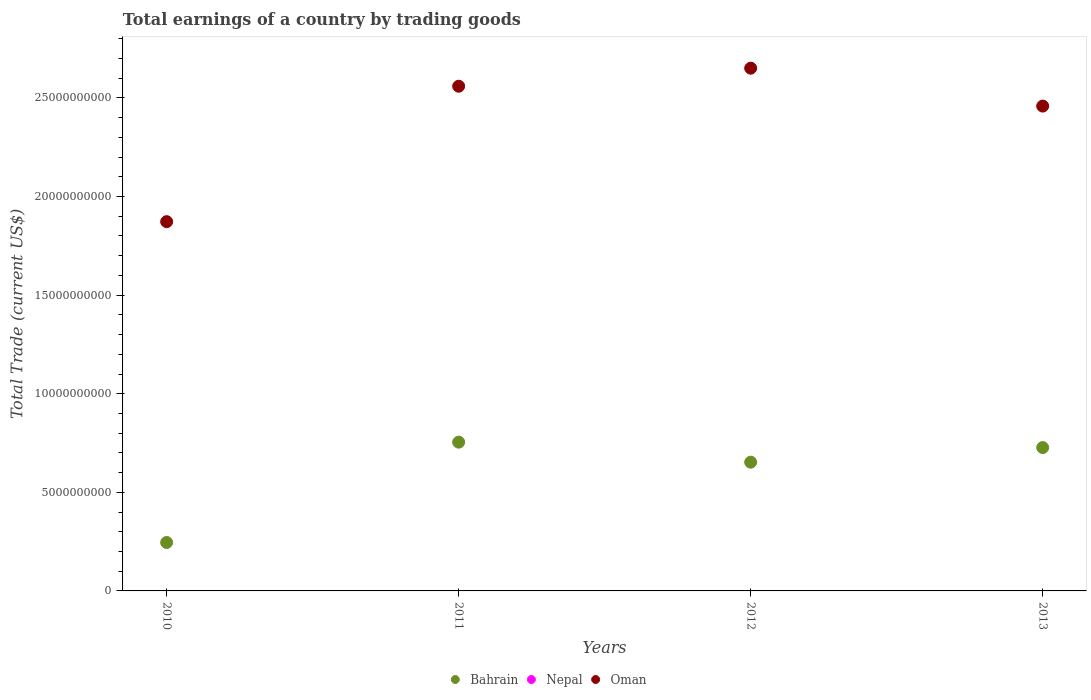What is the total earnings in Bahrain in 2010?
Make the answer very short. 2.46e+09. Across all years, what is the maximum total earnings in Oman?
Offer a terse response. 2.65e+1. Across all years, what is the minimum total earnings in Bahrain?
Make the answer very short. 2.46e+09. In which year was the total earnings in Bahrain maximum?
Keep it short and to the point. 2011. What is the total total earnings in Bahrain in the graph?
Your answer should be compact. 2.38e+1. What is the difference between the total earnings in Oman in 2012 and that in 2013?
Your answer should be very brief. 1.92e+09. What is the difference between the total earnings in Oman in 2013 and the total earnings in Bahrain in 2010?
Your answer should be very brief. 2.21e+1. In the year 2010, what is the difference between the total earnings in Bahrain and total earnings in Oman?
Keep it short and to the point. -1.63e+1. What is the ratio of the total earnings in Oman in 2010 to that in 2012?
Provide a succinct answer. 0.71. Is the difference between the total earnings in Bahrain in 2010 and 2011 greater than the difference between the total earnings in Oman in 2010 and 2011?
Your response must be concise. Yes. What is the difference between the highest and the second highest total earnings in Oman?
Offer a terse response. 9.15e+08. What is the difference between the highest and the lowest total earnings in Oman?
Ensure brevity in your answer.  7.78e+09. Is it the case that in every year, the sum of the total earnings in Bahrain and total earnings in Oman  is greater than the total earnings in Nepal?
Ensure brevity in your answer.  Yes. Is the total earnings in Nepal strictly less than the total earnings in Oman over the years?
Offer a very short reply. Yes. How many dotlines are there?
Provide a succinct answer. 2. How many years are there in the graph?
Offer a very short reply. 4. What is the difference between two consecutive major ticks on the Y-axis?
Your answer should be very brief. 5.00e+09. Are the values on the major ticks of Y-axis written in scientific E-notation?
Provide a succinct answer. No. How many legend labels are there?
Offer a very short reply. 3. How are the legend labels stacked?
Provide a short and direct response. Horizontal. What is the title of the graph?
Your response must be concise. Total earnings of a country by trading goods. Does "Arab World" appear as one of the legend labels in the graph?
Offer a very short reply. No. What is the label or title of the Y-axis?
Your answer should be compact. Total Trade (current US$). What is the Total Trade (current US$) in Bahrain in 2010?
Offer a very short reply. 2.46e+09. What is the Total Trade (current US$) in Oman in 2010?
Ensure brevity in your answer.  1.87e+1. What is the Total Trade (current US$) of Bahrain in 2011?
Provide a succinct answer. 7.54e+09. What is the Total Trade (current US$) in Oman in 2011?
Ensure brevity in your answer.  2.56e+1. What is the Total Trade (current US$) of Bahrain in 2012?
Give a very brief answer. 6.53e+09. What is the Total Trade (current US$) of Nepal in 2012?
Your answer should be very brief. 0. What is the Total Trade (current US$) of Oman in 2012?
Make the answer very short. 2.65e+1. What is the Total Trade (current US$) in Bahrain in 2013?
Your answer should be very brief. 7.27e+09. What is the Total Trade (current US$) of Oman in 2013?
Provide a short and direct response. 2.46e+1. Across all years, what is the maximum Total Trade (current US$) of Bahrain?
Keep it short and to the point. 7.54e+09. Across all years, what is the maximum Total Trade (current US$) of Oman?
Provide a succinct answer. 2.65e+1. Across all years, what is the minimum Total Trade (current US$) in Bahrain?
Provide a succinct answer. 2.46e+09. Across all years, what is the minimum Total Trade (current US$) in Oman?
Provide a short and direct response. 1.87e+1. What is the total Total Trade (current US$) in Bahrain in the graph?
Make the answer very short. 2.38e+1. What is the total Total Trade (current US$) of Oman in the graph?
Your response must be concise. 9.54e+1. What is the difference between the Total Trade (current US$) of Bahrain in 2010 and that in 2011?
Make the answer very short. -5.09e+09. What is the difference between the Total Trade (current US$) of Oman in 2010 and that in 2011?
Give a very brief answer. -6.87e+09. What is the difference between the Total Trade (current US$) in Bahrain in 2010 and that in 2012?
Make the answer very short. -4.07e+09. What is the difference between the Total Trade (current US$) of Oman in 2010 and that in 2012?
Keep it short and to the point. -7.78e+09. What is the difference between the Total Trade (current US$) in Bahrain in 2010 and that in 2013?
Offer a very short reply. -4.81e+09. What is the difference between the Total Trade (current US$) in Oman in 2010 and that in 2013?
Your response must be concise. -5.86e+09. What is the difference between the Total Trade (current US$) in Bahrain in 2011 and that in 2012?
Your answer should be very brief. 1.02e+09. What is the difference between the Total Trade (current US$) in Oman in 2011 and that in 2012?
Offer a terse response. -9.15e+08. What is the difference between the Total Trade (current US$) in Bahrain in 2011 and that in 2013?
Offer a very short reply. 2.74e+08. What is the difference between the Total Trade (current US$) of Oman in 2011 and that in 2013?
Your answer should be compact. 1.01e+09. What is the difference between the Total Trade (current US$) of Bahrain in 2012 and that in 2013?
Your response must be concise. -7.41e+08. What is the difference between the Total Trade (current US$) of Oman in 2012 and that in 2013?
Keep it short and to the point. 1.92e+09. What is the difference between the Total Trade (current US$) of Bahrain in 2010 and the Total Trade (current US$) of Oman in 2011?
Your answer should be very brief. -2.31e+1. What is the difference between the Total Trade (current US$) in Bahrain in 2010 and the Total Trade (current US$) in Oman in 2012?
Provide a succinct answer. -2.41e+1. What is the difference between the Total Trade (current US$) of Bahrain in 2010 and the Total Trade (current US$) of Oman in 2013?
Provide a succinct answer. -2.21e+1. What is the difference between the Total Trade (current US$) of Bahrain in 2011 and the Total Trade (current US$) of Oman in 2012?
Your answer should be compact. -1.90e+1. What is the difference between the Total Trade (current US$) in Bahrain in 2011 and the Total Trade (current US$) in Oman in 2013?
Offer a very short reply. -1.70e+1. What is the difference between the Total Trade (current US$) of Bahrain in 2012 and the Total Trade (current US$) of Oman in 2013?
Ensure brevity in your answer.  -1.81e+1. What is the average Total Trade (current US$) in Bahrain per year?
Your response must be concise. 5.95e+09. What is the average Total Trade (current US$) in Nepal per year?
Keep it short and to the point. 0. What is the average Total Trade (current US$) of Oman per year?
Your response must be concise. 2.39e+1. In the year 2010, what is the difference between the Total Trade (current US$) of Bahrain and Total Trade (current US$) of Oman?
Give a very brief answer. -1.63e+1. In the year 2011, what is the difference between the Total Trade (current US$) in Bahrain and Total Trade (current US$) in Oman?
Provide a short and direct response. -1.81e+1. In the year 2012, what is the difference between the Total Trade (current US$) in Bahrain and Total Trade (current US$) in Oman?
Ensure brevity in your answer.  -2.00e+1. In the year 2013, what is the difference between the Total Trade (current US$) in Bahrain and Total Trade (current US$) in Oman?
Give a very brief answer. -1.73e+1. What is the ratio of the Total Trade (current US$) of Bahrain in 2010 to that in 2011?
Your answer should be compact. 0.33. What is the ratio of the Total Trade (current US$) of Oman in 2010 to that in 2011?
Your response must be concise. 0.73. What is the ratio of the Total Trade (current US$) of Bahrain in 2010 to that in 2012?
Your answer should be compact. 0.38. What is the ratio of the Total Trade (current US$) in Oman in 2010 to that in 2012?
Your answer should be very brief. 0.71. What is the ratio of the Total Trade (current US$) of Bahrain in 2010 to that in 2013?
Make the answer very short. 0.34. What is the ratio of the Total Trade (current US$) of Oman in 2010 to that in 2013?
Offer a terse response. 0.76. What is the ratio of the Total Trade (current US$) of Bahrain in 2011 to that in 2012?
Provide a short and direct response. 1.16. What is the ratio of the Total Trade (current US$) of Oman in 2011 to that in 2012?
Your response must be concise. 0.97. What is the ratio of the Total Trade (current US$) in Bahrain in 2011 to that in 2013?
Keep it short and to the point. 1.04. What is the ratio of the Total Trade (current US$) of Oman in 2011 to that in 2013?
Your answer should be very brief. 1.04. What is the ratio of the Total Trade (current US$) of Bahrain in 2012 to that in 2013?
Your response must be concise. 0.9. What is the ratio of the Total Trade (current US$) of Oman in 2012 to that in 2013?
Your answer should be very brief. 1.08. What is the difference between the highest and the second highest Total Trade (current US$) of Bahrain?
Make the answer very short. 2.74e+08. What is the difference between the highest and the second highest Total Trade (current US$) in Oman?
Make the answer very short. 9.15e+08. What is the difference between the highest and the lowest Total Trade (current US$) of Bahrain?
Ensure brevity in your answer.  5.09e+09. What is the difference between the highest and the lowest Total Trade (current US$) in Oman?
Make the answer very short. 7.78e+09. 